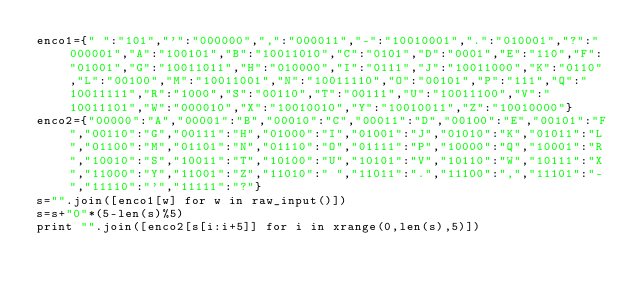<code> <loc_0><loc_0><loc_500><loc_500><_Python_>enco1={" ":"101","'":"000000",",":"000011","-":"10010001",".":"010001","?":"000001","A":"100101","B":"10011010","C":"0101","D":"0001","E":"110","F":"01001","G":"10011011","H":"010000","I":"0111","J":"10011000","K":"0110","L":"00100","M":"10011001","N":"10011110","O":"00101","P":"111","Q":"10011111","R":"1000","S":"00110","T":"00111","U":"10011100","V":"10011101","W":"000010","X":"10010010","Y":"10010011","Z":"10010000"}
enco2={"00000":"A","00001":"B","00010":"C","00011":"D","00100":"E","00101":"F","00110":"G","00111":"H","01000":"I","01001":"J","01010":"K","01011":"L","01100":"M","01101":"N","01110":"O","01111":"P","10000":"Q","10001":"R","10010":"S","10011":"T","10100":"U","10101":"V","10110":"W","10111":"X","11000":"Y","11001":"Z","11010":" ","11011":".","11100":",","11101":"-","11110":"'","11111":"?"}
s="".join([enco1[w] for w in raw_input()])
s=s+"0"*(5-len(s)%5)
print "".join([enco2[s[i:i+5]] for i in xrange(0,len(s),5)])</code> 